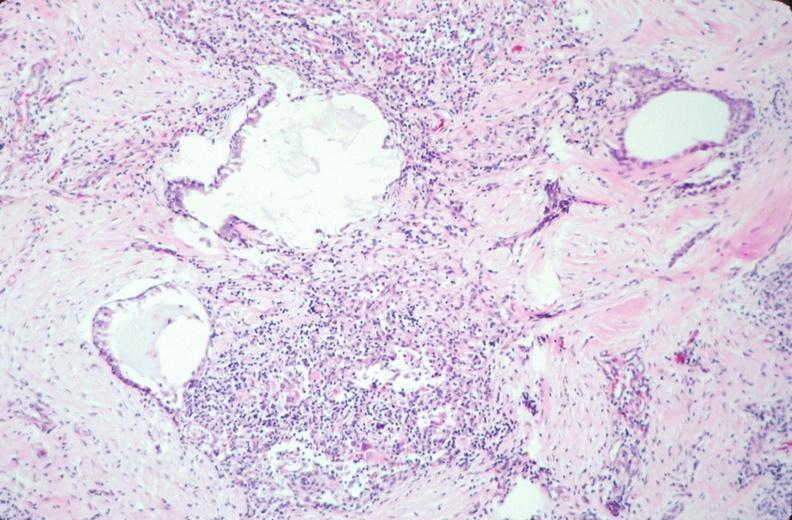does this image show pharyngeal pouch remnant, incidental finding in an adult?
Answer the question using a single word or phrase. Yes 